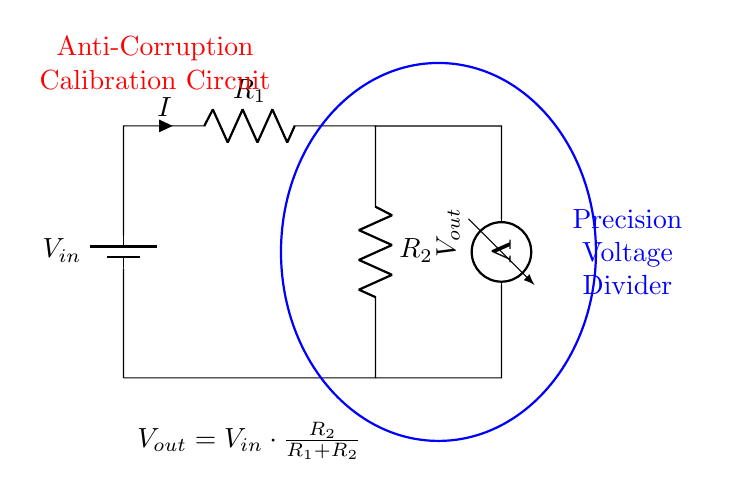What is the input voltage of this circuit? The input voltage, labeled as V_in, is the voltage supplied to the circuit from the battery in the diagram.
Answer: V_in What is the purpose of the voltmeter in this circuit? The voltmeter is used to measure the output voltage (V_out) across the resistor R_2. It is connected in parallel to R_2 and provides a reading of the voltage drop across it.
Answer: Measure V_out What are the values of the resistors in this circuit? The resistors are labeled as R_1 and R_2 but the specific values are not provided in the diagram. They typically need to be defined based on design specifications.
Answer: R_1 and R_2 How is the output voltage calculated in this voltage divider? The output voltage (V_out) is determined using the formula V_out = V_in * (R_2 / (R_1 + R_2)). This shows that the output voltage is a fraction of the input voltage based on the resistor values.
Answer: V_out = V_in * (R_2 / (R_1 + R_2)) If R_1 is twice the value of R_2, what is the ratio of V_out to V_in? If R_1 is twice R_2, then using the voltage divider formula V_out = V_in * (R_2 / (R_1 + R_2)), the output voltage becomes V_in / 3 since R_2 is 1 part and R_1 is 2 parts. Therefore, V_out is one-third of V_in.
Answer: One-third What configuration does this circuit represent? This is a Voltage Divider configuration consisting of two resistors in series, where the output voltage is taken from the junction of the two resistors.
Answer: Voltage Divider What happens to V_out if R_2 is made very large compared to R_1? If R_2 is much larger than R_1, the output voltage (V_out) approaches the input voltage (V_in) as the fraction (R_2 / (R_1 + R_2)) approaches 1. Thus, V_out will be nearly equal to V_in.
Answer: Nearly equal to V_in 